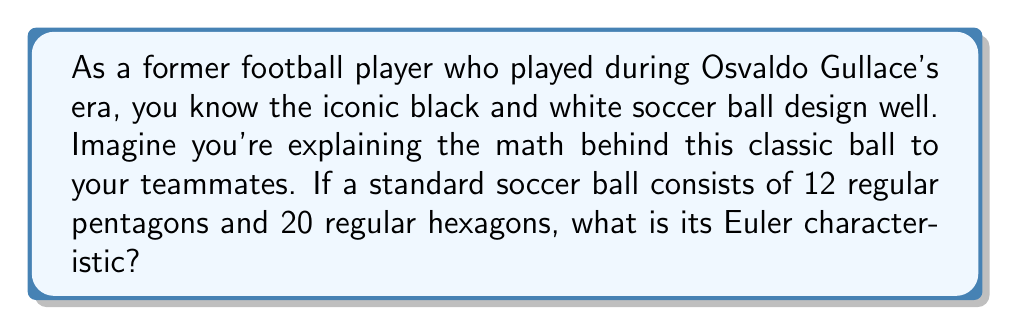Can you answer this question? Let's approach this step-by-step, using the knowledge of the ball's structure:

1) First, recall the Euler characteristic formula:
   $$\chi = V - E + F$$
   where $\chi$ is the Euler characteristic, $V$ is the number of vertices, $E$ is the number of edges, and $F$ is the number of faces.

2) Let's count the faces (F):
   - 12 pentagons
   - 20 hexagons
   $F = 12 + 20 = 32$

3) Now, let's count the vertices (V):
   - Each vertex is where three faces meet (imagine the corner of a pentagon touching two hexagons)
   - We can use the formula: $V = \frac{5 \cdot 12 + 6 \cdot 20}{3} = 60$
   This works because each pentagon contributes 5 vertices, each hexagon contributes 6, but each vertex is counted 3 times.

4) For the edges (E):
   - We can use the formula: $E = \frac{5 \cdot 12 + 6 \cdot 20}{2} = 90$
   This works because each pentagon has 5 edges, each hexagon has 6, but each edge is counted twice.

5) Now we can calculate the Euler characteristic:
   $$\chi = V - E + F = 60 - 90 + 32 = 2$$

This result, $\chi = 2$, is consistent with the fact that a soccer ball is topologically equivalent to a sphere.
Answer: $\chi = 2$ 